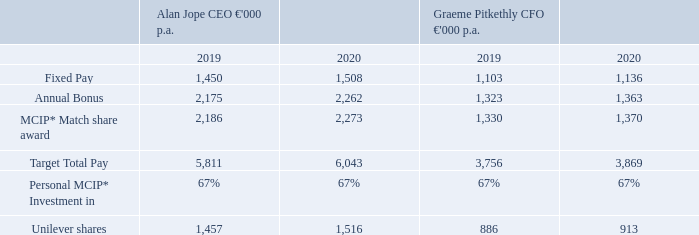Executive Director Fixed Pay increases
The Committee has approved Fixed Pay increases of 4% for the CEO and 3% for the CFO, effective from 1 January 2020. This is in line with the average increase awarded to the wider Unilever workforce in 2019 of 3.6%. These increases were awarded to recognise the strong leadership of both individuals in 2019, which was Alan Jope’s first year in the CEO role and a year of transformation for Unilever generally. We also wanted to recognise Graeme Pitkethly’s seniority in his role, coming into his 5th year as CFO.
When our CEO Alan Jope was appointed on 1 January 2019 he was appointed with Fixed Pay 14% below that of what the Committee proposed for his predecessor and at the lower quartile of our remuneration benchmarking peer group, despite Unilever being one of the largest companies in this peer group. This positioning was intentional, given Alan’s internal promotion on appointment. However, subject to Alan’s continuing good performance the Committee will, over time, continue to review his Fixed Pay positioning and progress this towards the market median benchmark.
* MCIP at maximum (67%) investment of bonus.
What is the increase in the Fixed Pay approved by the committee? The committee has approved fixed pay increases of 4% for the ceo and 3% for the cfo, effective from 1 january 2020. Who were these increases awarded to? These increases were awarded to recognise the strong leadership of both individuals in 2019, which was alan jope’s first year in the ceo role and a year of transformation for unilever generally. we also wanted to recognise graeme pitkethly’s seniority in his role, coming into his 5th year as cfo. What was the Fixed Pay percentage when CEO Alan Jope joined? 14%. What is the increase / (decrease) in Fixed Pay for Alan Jope CEO from 2019 to 2020?
Answer scale should be: million. 1,450 - 1,508
Answer: -58. What is the percentage difference between the Fixed pay of CEO and CFO in 2020?
Answer scale should be: percent. 1,508 / 1,136 - 1
Answer: 32.75. What is the difference in the target total pay between CEO and CFO in 2020?
Answer scale should be: million. 6,043 - 3,869
Answer: 2174. 